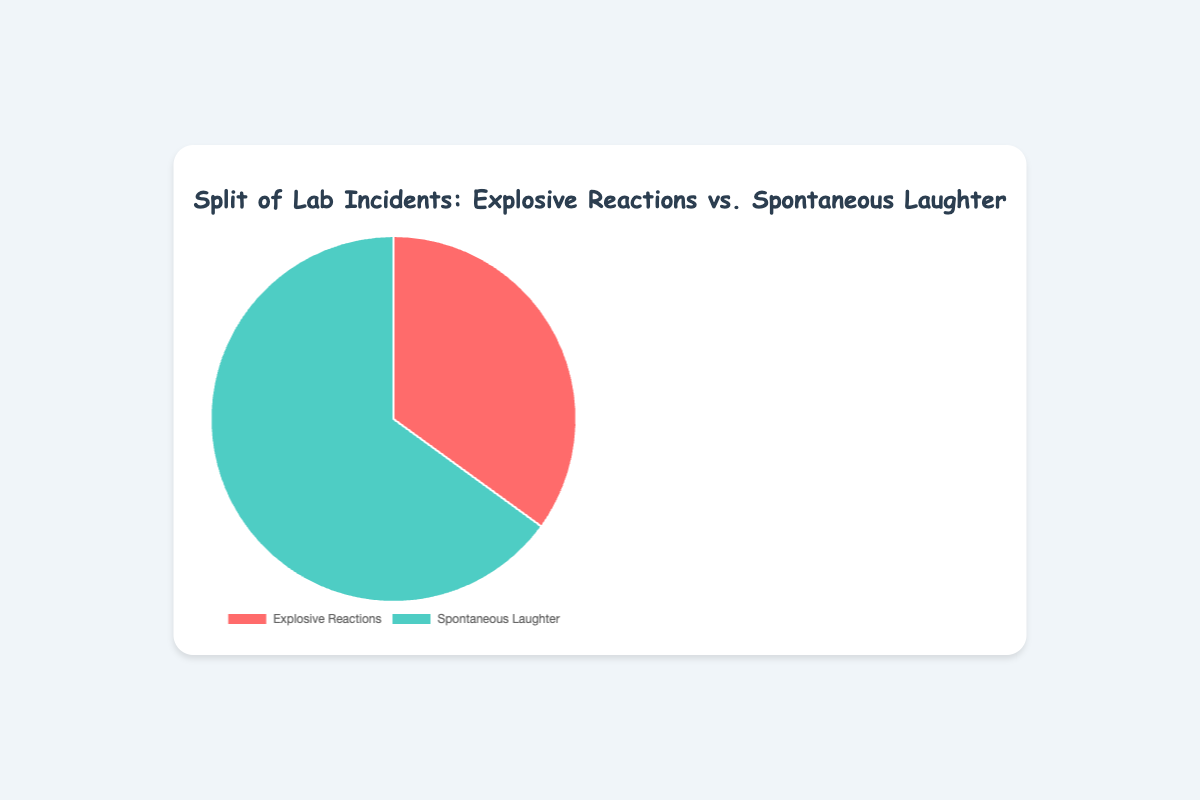Which type of lab incident happens more frequently? We observe from the pie chart that "Spontaneous Laughter" occupies a larger portion compared to "Explosive Reactions". Therefore, "Spontaneous Laughter" happens more frequently.
Answer: Spontaneous Laughter What percentage of lab incidents are Explosive Reactions? The pie chart indicates that 35% of lab incidents are categorized as "Explosive Reactions".
Answer: 35% By how many percentage points do Spontaneous Laughter incidents outnumber Explosive Reactions? Spontaneous Laughter incidents make up 65% and Explosive Reactions are 35%. The difference is calculated as 65% - 35% = 30%.
Answer: 30% If you were to combine the percentages of both types of incidents, what would the total be? Since the pie chart represents the entire set of lab incidents divided into "Explosive Reactions" and "Spontaneous Laughter", their combined total equals 100%.
Answer: 100% How much larger is the section representing Spontaneous Laughter compared to Explosive Reactions in terms of visual size? Visually, the section for Spontaneous Laughter is almost twice as large as that for Explosive Reactions since 65% is nearly double 35%.
Answer: Almost twice as large If an additional category of "Mild Mishaps" were added, taking 10% of the incidents from both existing categories proportionally, what would be the new percentages for each category? 10% of 100% is 10%, so 10% would take 3.5% from Explosive Reactions (reducing it to 31.5%) and 6.5% from Spontaneous Laughter (reducing it to 58.5%).
Answer: Explosive Reactions: 31.5%, Spontaneous Laughter: 58.5% Which color represents the category with more incidents, and what is that color? The category "Spontaneous Laughter" has more incidents and is represented by the color green in the pie chart.
Answer: Green What is the ratio of Spontaneous Laughter to Explosive Reactions incidents? To find the ratio, divide the percentage of Spontaneous Laughter by the percentage of Explosive Reactions: 65 / 35 = 1.857. This can be roughly approximated to 1.86 or about 13:7.
Answer: About 1.86:1 or 13:7 